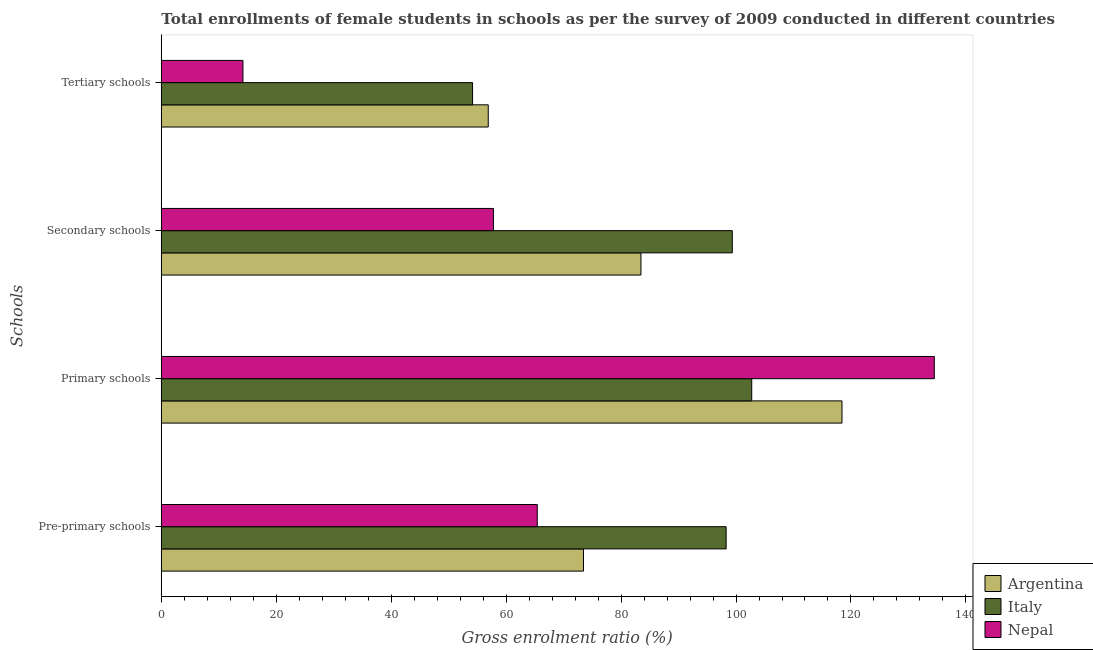How many groups of bars are there?
Offer a terse response. 4. Are the number of bars per tick equal to the number of legend labels?
Offer a terse response. Yes. Are the number of bars on each tick of the Y-axis equal?
Your response must be concise. Yes. How many bars are there on the 2nd tick from the top?
Your answer should be very brief. 3. How many bars are there on the 2nd tick from the bottom?
Provide a short and direct response. 3. What is the label of the 3rd group of bars from the top?
Offer a very short reply. Primary schools. What is the gross enrolment ratio(female) in pre-primary schools in Nepal?
Make the answer very short. 65.42. Across all countries, what is the maximum gross enrolment ratio(female) in secondary schools?
Your answer should be compact. 99.35. Across all countries, what is the minimum gross enrolment ratio(female) in primary schools?
Ensure brevity in your answer.  102.73. In which country was the gross enrolment ratio(female) in primary schools maximum?
Provide a short and direct response. Nepal. What is the total gross enrolment ratio(female) in primary schools in the graph?
Your answer should be very brief. 355.68. What is the difference between the gross enrolment ratio(female) in tertiary schools in Argentina and that in Italy?
Give a very brief answer. 2.73. What is the difference between the gross enrolment ratio(female) in pre-primary schools in Italy and the gross enrolment ratio(female) in tertiary schools in Nepal?
Your answer should be very brief. 84.08. What is the average gross enrolment ratio(female) in primary schools per country?
Your answer should be compact. 118.56. What is the difference between the gross enrolment ratio(female) in pre-primary schools and gross enrolment ratio(female) in secondary schools in Nepal?
Keep it short and to the point. 7.63. In how many countries, is the gross enrolment ratio(female) in secondary schools greater than 80 %?
Give a very brief answer. 2. What is the ratio of the gross enrolment ratio(female) in primary schools in Nepal to that in Argentina?
Ensure brevity in your answer.  1.14. Is the gross enrolment ratio(female) in tertiary schools in Argentina less than that in Italy?
Keep it short and to the point. No. What is the difference between the highest and the second highest gross enrolment ratio(female) in secondary schools?
Your answer should be very brief. 15.9. What is the difference between the highest and the lowest gross enrolment ratio(female) in primary schools?
Offer a terse response. 31.77. In how many countries, is the gross enrolment ratio(female) in secondary schools greater than the average gross enrolment ratio(female) in secondary schools taken over all countries?
Keep it short and to the point. 2. Is the sum of the gross enrolment ratio(female) in tertiary schools in Nepal and Argentina greater than the maximum gross enrolment ratio(female) in primary schools across all countries?
Offer a terse response. No. Is it the case that in every country, the sum of the gross enrolment ratio(female) in pre-primary schools and gross enrolment ratio(female) in primary schools is greater than the sum of gross enrolment ratio(female) in secondary schools and gross enrolment ratio(female) in tertiary schools?
Give a very brief answer. No. What does the 1st bar from the top in Secondary schools represents?
Give a very brief answer. Nepal. What does the 3rd bar from the bottom in Secondary schools represents?
Keep it short and to the point. Nepal. Are all the bars in the graph horizontal?
Provide a succinct answer. Yes. How many legend labels are there?
Provide a short and direct response. 3. How are the legend labels stacked?
Ensure brevity in your answer.  Vertical. What is the title of the graph?
Keep it short and to the point. Total enrollments of female students in schools as per the survey of 2009 conducted in different countries. What is the label or title of the X-axis?
Give a very brief answer. Gross enrolment ratio (%). What is the label or title of the Y-axis?
Ensure brevity in your answer.  Schools. What is the Gross enrolment ratio (%) in Argentina in Pre-primary schools?
Your response must be concise. 73.46. What is the Gross enrolment ratio (%) in Italy in Pre-primary schools?
Offer a very short reply. 98.28. What is the Gross enrolment ratio (%) of Nepal in Pre-primary schools?
Make the answer very short. 65.42. What is the Gross enrolment ratio (%) in Argentina in Primary schools?
Make the answer very short. 118.44. What is the Gross enrolment ratio (%) in Italy in Primary schools?
Your response must be concise. 102.73. What is the Gross enrolment ratio (%) in Nepal in Primary schools?
Provide a short and direct response. 134.5. What is the Gross enrolment ratio (%) in Argentina in Secondary schools?
Make the answer very short. 83.45. What is the Gross enrolment ratio (%) of Italy in Secondary schools?
Keep it short and to the point. 99.35. What is the Gross enrolment ratio (%) of Nepal in Secondary schools?
Provide a succinct answer. 57.79. What is the Gross enrolment ratio (%) of Argentina in Tertiary schools?
Offer a terse response. 56.89. What is the Gross enrolment ratio (%) in Italy in Tertiary schools?
Your answer should be very brief. 54.16. What is the Gross enrolment ratio (%) of Nepal in Tertiary schools?
Your answer should be very brief. 14.2. Across all Schools, what is the maximum Gross enrolment ratio (%) in Argentina?
Ensure brevity in your answer.  118.44. Across all Schools, what is the maximum Gross enrolment ratio (%) in Italy?
Make the answer very short. 102.73. Across all Schools, what is the maximum Gross enrolment ratio (%) in Nepal?
Offer a very short reply. 134.5. Across all Schools, what is the minimum Gross enrolment ratio (%) in Argentina?
Ensure brevity in your answer.  56.89. Across all Schools, what is the minimum Gross enrolment ratio (%) of Italy?
Make the answer very short. 54.16. Across all Schools, what is the minimum Gross enrolment ratio (%) in Nepal?
Ensure brevity in your answer.  14.2. What is the total Gross enrolment ratio (%) in Argentina in the graph?
Provide a short and direct response. 332.24. What is the total Gross enrolment ratio (%) of Italy in the graph?
Keep it short and to the point. 354.52. What is the total Gross enrolment ratio (%) of Nepal in the graph?
Give a very brief answer. 271.91. What is the difference between the Gross enrolment ratio (%) of Argentina in Pre-primary schools and that in Primary schools?
Offer a terse response. -44.97. What is the difference between the Gross enrolment ratio (%) of Italy in Pre-primary schools and that in Primary schools?
Offer a very short reply. -4.46. What is the difference between the Gross enrolment ratio (%) of Nepal in Pre-primary schools and that in Primary schools?
Make the answer very short. -69.09. What is the difference between the Gross enrolment ratio (%) of Argentina in Pre-primary schools and that in Secondary schools?
Provide a short and direct response. -9.99. What is the difference between the Gross enrolment ratio (%) in Italy in Pre-primary schools and that in Secondary schools?
Give a very brief answer. -1.07. What is the difference between the Gross enrolment ratio (%) of Nepal in Pre-primary schools and that in Secondary schools?
Your answer should be very brief. 7.63. What is the difference between the Gross enrolment ratio (%) of Argentina in Pre-primary schools and that in Tertiary schools?
Provide a succinct answer. 16.58. What is the difference between the Gross enrolment ratio (%) of Italy in Pre-primary schools and that in Tertiary schools?
Ensure brevity in your answer.  44.12. What is the difference between the Gross enrolment ratio (%) in Nepal in Pre-primary schools and that in Tertiary schools?
Ensure brevity in your answer.  51.21. What is the difference between the Gross enrolment ratio (%) of Argentina in Primary schools and that in Secondary schools?
Ensure brevity in your answer.  34.98. What is the difference between the Gross enrolment ratio (%) in Italy in Primary schools and that in Secondary schools?
Offer a very short reply. 3.38. What is the difference between the Gross enrolment ratio (%) of Nepal in Primary schools and that in Secondary schools?
Ensure brevity in your answer.  76.72. What is the difference between the Gross enrolment ratio (%) of Argentina in Primary schools and that in Tertiary schools?
Ensure brevity in your answer.  61.55. What is the difference between the Gross enrolment ratio (%) of Italy in Primary schools and that in Tertiary schools?
Ensure brevity in your answer.  48.58. What is the difference between the Gross enrolment ratio (%) of Nepal in Primary schools and that in Tertiary schools?
Offer a very short reply. 120.3. What is the difference between the Gross enrolment ratio (%) in Argentina in Secondary schools and that in Tertiary schools?
Give a very brief answer. 26.57. What is the difference between the Gross enrolment ratio (%) of Italy in Secondary schools and that in Tertiary schools?
Your response must be concise. 45.2. What is the difference between the Gross enrolment ratio (%) of Nepal in Secondary schools and that in Tertiary schools?
Provide a short and direct response. 43.59. What is the difference between the Gross enrolment ratio (%) of Argentina in Pre-primary schools and the Gross enrolment ratio (%) of Italy in Primary schools?
Keep it short and to the point. -29.27. What is the difference between the Gross enrolment ratio (%) of Argentina in Pre-primary schools and the Gross enrolment ratio (%) of Nepal in Primary schools?
Your answer should be compact. -61.04. What is the difference between the Gross enrolment ratio (%) in Italy in Pre-primary schools and the Gross enrolment ratio (%) in Nepal in Primary schools?
Your response must be concise. -36.23. What is the difference between the Gross enrolment ratio (%) of Argentina in Pre-primary schools and the Gross enrolment ratio (%) of Italy in Secondary schools?
Your answer should be compact. -25.89. What is the difference between the Gross enrolment ratio (%) of Argentina in Pre-primary schools and the Gross enrolment ratio (%) of Nepal in Secondary schools?
Your answer should be very brief. 15.67. What is the difference between the Gross enrolment ratio (%) in Italy in Pre-primary schools and the Gross enrolment ratio (%) in Nepal in Secondary schools?
Your response must be concise. 40.49. What is the difference between the Gross enrolment ratio (%) of Argentina in Pre-primary schools and the Gross enrolment ratio (%) of Italy in Tertiary schools?
Ensure brevity in your answer.  19.31. What is the difference between the Gross enrolment ratio (%) of Argentina in Pre-primary schools and the Gross enrolment ratio (%) of Nepal in Tertiary schools?
Offer a very short reply. 59.26. What is the difference between the Gross enrolment ratio (%) of Italy in Pre-primary schools and the Gross enrolment ratio (%) of Nepal in Tertiary schools?
Your response must be concise. 84.08. What is the difference between the Gross enrolment ratio (%) of Argentina in Primary schools and the Gross enrolment ratio (%) of Italy in Secondary schools?
Offer a terse response. 19.08. What is the difference between the Gross enrolment ratio (%) in Argentina in Primary schools and the Gross enrolment ratio (%) in Nepal in Secondary schools?
Your answer should be very brief. 60.65. What is the difference between the Gross enrolment ratio (%) in Italy in Primary schools and the Gross enrolment ratio (%) in Nepal in Secondary schools?
Give a very brief answer. 44.95. What is the difference between the Gross enrolment ratio (%) of Argentina in Primary schools and the Gross enrolment ratio (%) of Italy in Tertiary schools?
Provide a short and direct response. 64.28. What is the difference between the Gross enrolment ratio (%) in Argentina in Primary schools and the Gross enrolment ratio (%) in Nepal in Tertiary schools?
Offer a terse response. 104.23. What is the difference between the Gross enrolment ratio (%) of Italy in Primary schools and the Gross enrolment ratio (%) of Nepal in Tertiary schools?
Your answer should be very brief. 88.53. What is the difference between the Gross enrolment ratio (%) in Argentina in Secondary schools and the Gross enrolment ratio (%) in Italy in Tertiary schools?
Keep it short and to the point. 29.3. What is the difference between the Gross enrolment ratio (%) of Argentina in Secondary schools and the Gross enrolment ratio (%) of Nepal in Tertiary schools?
Ensure brevity in your answer.  69.25. What is the difference between the Gross enrolment ratio (%) of Italy in Secondary schools and the Gross enrolment ratio (%) of Nepal in Tertiary schools?
Make the answer very short. 85.15. What is the average Gross enrolment ratio (%) of Argentina per Schools?
Keep it short and to the point. 83.06. What is the average Gross enrolment ratio (%) in Italy per Schools?
Provide a succinct answer. 88.63. What is the average Gross enrolment ratio (%) in Nepal per Schools?
Keep it short and to the point. 67.98. What is the difference between the Gross enrolment ratio (%) of Argentina and Gross enrolment ratio (%) of Italy in Pre-primary schools?
Your answer should be compact. -24.82. What is the difference between the Gross enrolment ratio (%) of Argentina and Gross enrolment ratio (%) of Nepal in Pre-primary schools?
Your answer should be compact. 8.04. What is the difference between the Gross enrolment ratio (%) in Italy and Gross enrolment ratio (%) in Nepal in Pre-primary schools?
Provide a succinct answer. 32.86. What is the difference between the Gross enrolment ratio (%) in Argentina and Gross enrolment ratio (%) in Italy in Primary schools?
Provide a short and direct response. 15.7. What is the difference between the Gross enrolment ratio (%) of Argentina and Gross enrolment ratio (%) of Nepal in Primary schools?
Make the answer very short. -16.07. What is the difference between the Gross enrolment ratio (%) of Italy and Gross enrolment ratio (%) of Nepal in Primary schools?
Give a very brief answer. -31.77. What is the difference between the Gross enrolment ratio (%) in Argentina and Gross enrolment ratio (%) in Italy in Secondary schools?
Offer a very short reply. -15.9. What is the difference between the Gross enrolment ratio (%) in Argentina and Gross enrolment ratio (%) in Nepal in Secondary schools?
Provide a succinct answer. 25.67. What is the difference between the Gross enrolment ratio (%) in Italy and Gross enrolment ratio (%) in Nepal in Secondary schools?
Provide a succinct answer. 41.56. What is the difference between the Gross enrolment ratio (%) in Argentina and Gross enrolment ratio (%) in Italy in Tertiary schools?
Your response must be concise. 2.73. What is the difference between the Gross enrolment ratio (%) in Argentina and Gross enrolment ratio (%) in Nepal in Tertiary schools?
Provide a short and direct response. 42.68. What is the difference between the Gross enrolment ratio (%) in Italy and Gross enrolment ratio (%) in Nepal in Tertiary schools?
Your response must be concise. 39.95. What is the ratio of the Gross enrolment ratio (%) in Argentina in Pre-primary schools to that in Primary schools?
Give a very brief answer. 0.62. What is the ratio of the Gross enrolment ratio (%) of Italy in Pre-primary schools to that in Primary schools?
Give a very brief answer. 0.96. What is the ratio of the Gross enrolment ratio (%) of Nepal in Pre-primary schools to that in Primary schools?
Make the answer very short. 0.49. What is the ratio of the Gross enrolment ratio (%) in Argentina in Pre-primary schools to that in Secondary schools?
Offer a very short reply. 0.88. What is the ratio of the Gross enrolment ratio (%) in Italy in Pre-primary schools to that in Secondary schools?
Keep it short and to the point. 0.99. What is the ratio of the Gross enrolment ratio (%) of Nepal in Pre-primary schools to that in Secondary schools?
Offer a terse response. 1.13. What is the ratio of the Gross enrolment ratio (%) of Argentina in Pre-primary schools to that in Tertiary schools?
Provide a succinct answer. 1.29. What is the ratio of the Gross enrolment ratio (%) in Italy in Pre-primary schools to that in Tertiary schools?
Offer a very short reply. 1.81. What is the ratio of the Gross enrolment ratio (%) of Nepal in Pre-primary schools to that in Tertiary schools?
Offer a terse response. 4.61. What is the ratio of the Gross enrolment ratio (%) of Argentina in Primary schools to that in Secondary schools?
Offer a terse response. 1.42. What is the ratio of the Gross enrolment ratio (%) of Italy in Primary schools to that in Secondary schools?
Offer a terse response. 1.03. What is the ratio of the Gross enrolment ratio (%) in Nepal in Primary schools to that in Secondary schools?
Your answer should be very brief. 2.33. What is the ratio of the Gross enrolment ratio (%) in Argentina in Primary schools to that in Tertiary schools?
Your answer should be very brief. 2.08. What is the ratio of the Gross enrolment ratio (%) of Italy in Primary schools to that in Tertiary schools?
Give a very brief answer. 1.9. What is the ratio of the Gross enrolment ratio (%) of Nepal in Primary schools to that in Tertiary schools?
Provide a short and direct response. 9.47. What is the ratio of the Gross enrolment ratio (%) of Argentina in Secondary schools to that in Tertiary schools?
Your answer should be compact. 1.47. What is the ratio of the Gross enrolment ratio (%) of Italy in Secondary schools to that in Tertiary schools?
Provide a short and direct response. 1.83. What is the ratio of the Gross enrolment ratio (%) of Nepal in Secondary schools to that in Tertiary schools?
Your answer should be compact. 4.07. What is the difference between the highest and the second highest Gross enrolment ratio (%) of Argentina?
Offer a terse response. 34.98. What is the difference between the highest and the second highest Gross enrolment ratio (%) in Italy?
Offer a very short reply. 3.38. What is the difference between the highest and the second highest Gross enrolment ratio (%) of Nepal?
Offer a terse response. 69.09. What is the difference between the highest and the lowest Gross enrolment ratio (%) of Argentina?
Provide a short and direct response. 61.55. What is the difference between the highest and the lowest Gross enrolment ratio (%) in Italy?
Ensure brevity in your answer.  48.58. What is the difference between the highest and the lowest Gross enrolment ratio (%) in Nepal?
Give a very brief answer. 120.3. 